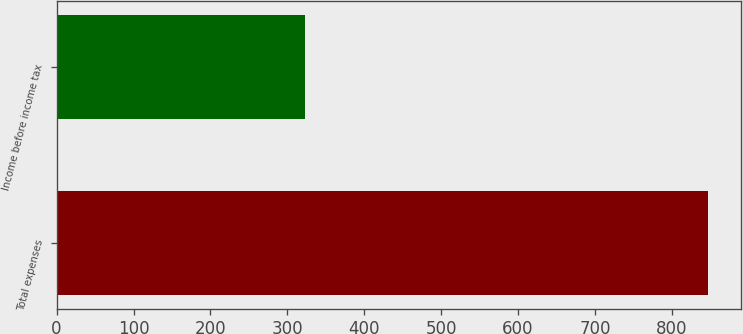Convert chart to OTSL. <chart><loc_0><loc_0><loc_500><loc_500><bar_chart><fcel>Total expenses<fcel>Income before income tax<nl><fcel>847<fcel>323<nl></chart> 